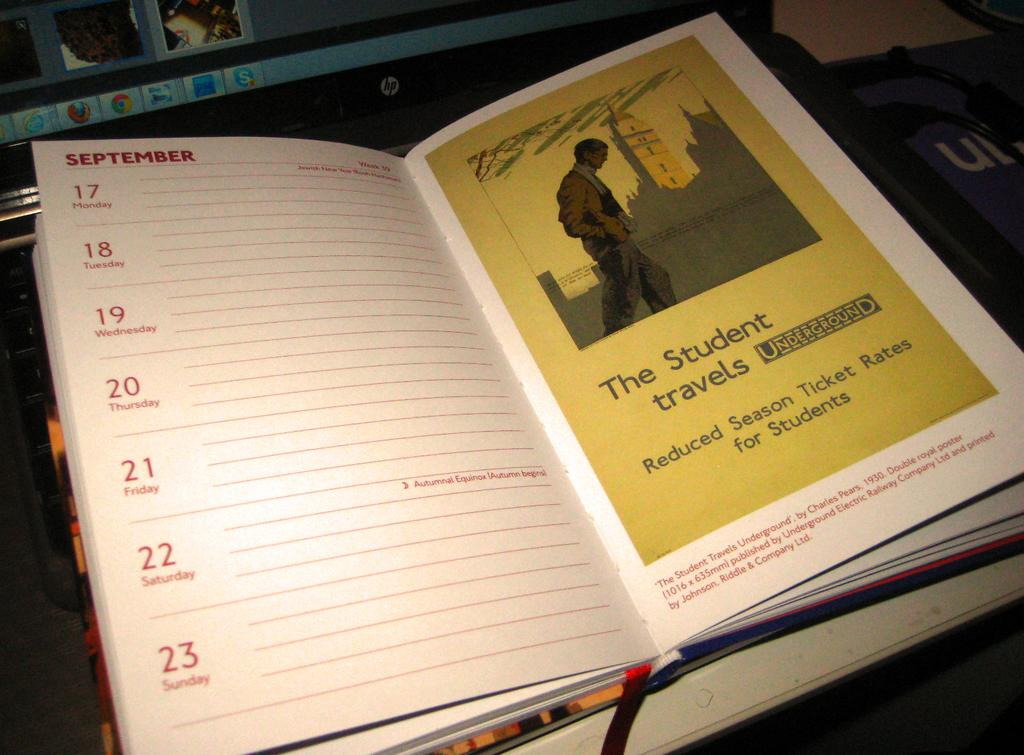Provide a one-sentence caption for the provided image. A open calendar book that is on the month of September. 